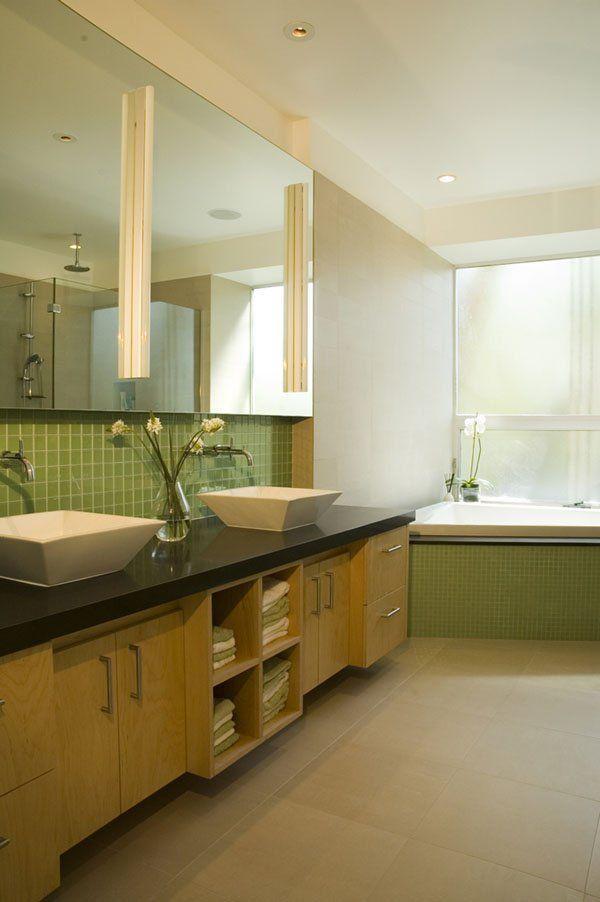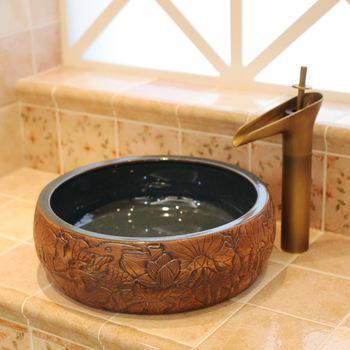The first image is the image on the left, the second image is the image on the right. Evaluate the accuracy of this statement regarding the images: "There is one vase with flowers in the right image.". Is it true? Answer yes or no. No. 